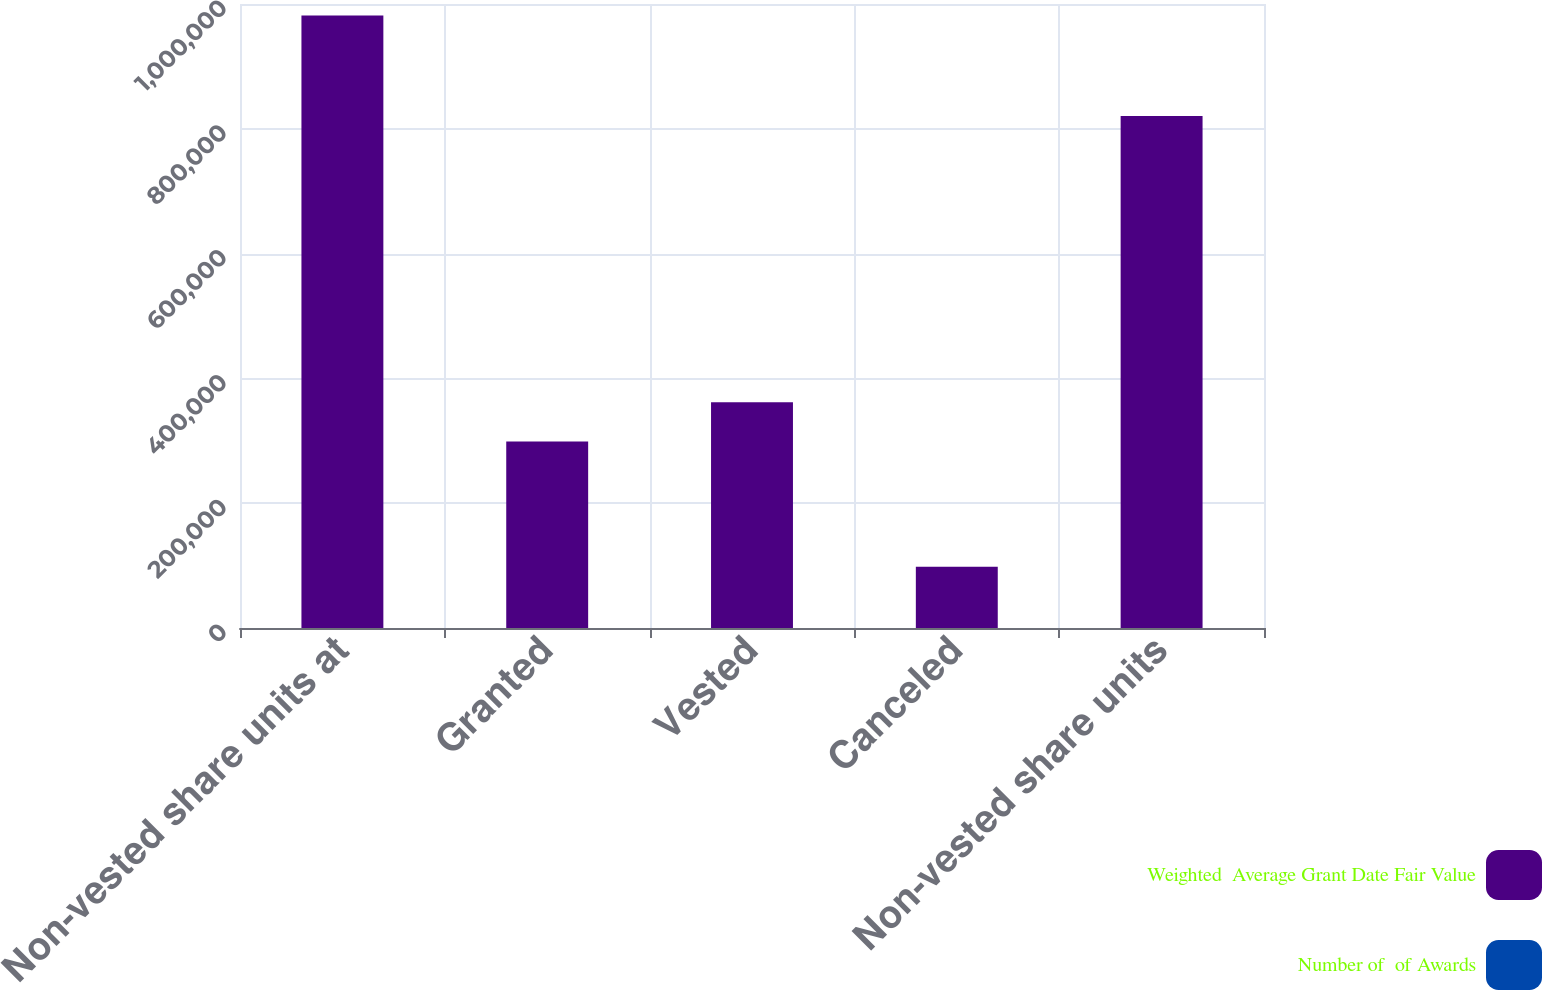Convert chart to OTSL. <chart><loc_0><loc_0><loc_500><loc_500><stacked_bar_chart><ecel><fcel>Non-vested share units at<fcel>Granted<fcel>Vested<fcel>Canceled<fcel>Non-vested share units<nl><fcel>Weighted  Average Grant Date Fair Value<fcel>981553<fcel>298998<fcel>361843<fcel>98059<fcel>820649<nl><fcel>Number of  of Awards<fcel>42.68<fcel>73.98<fcel>40.04<fcel>45.07<fcel>54.98<nl></chart> 